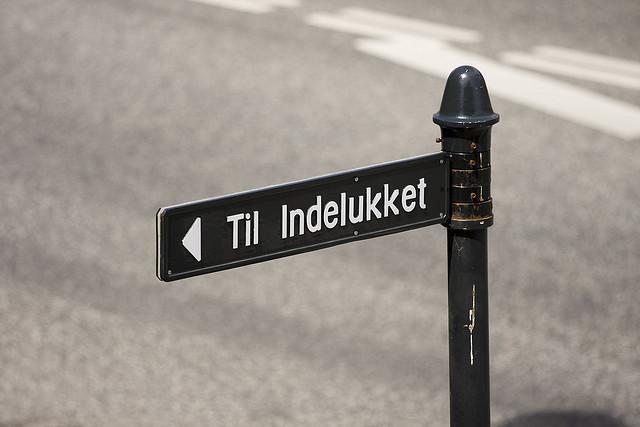What color is the sign?
Quick response, please. Black. What shape is on the sign?
Answer briefly. Triangle. Is the sign facing right?
Answer briefly. No. 